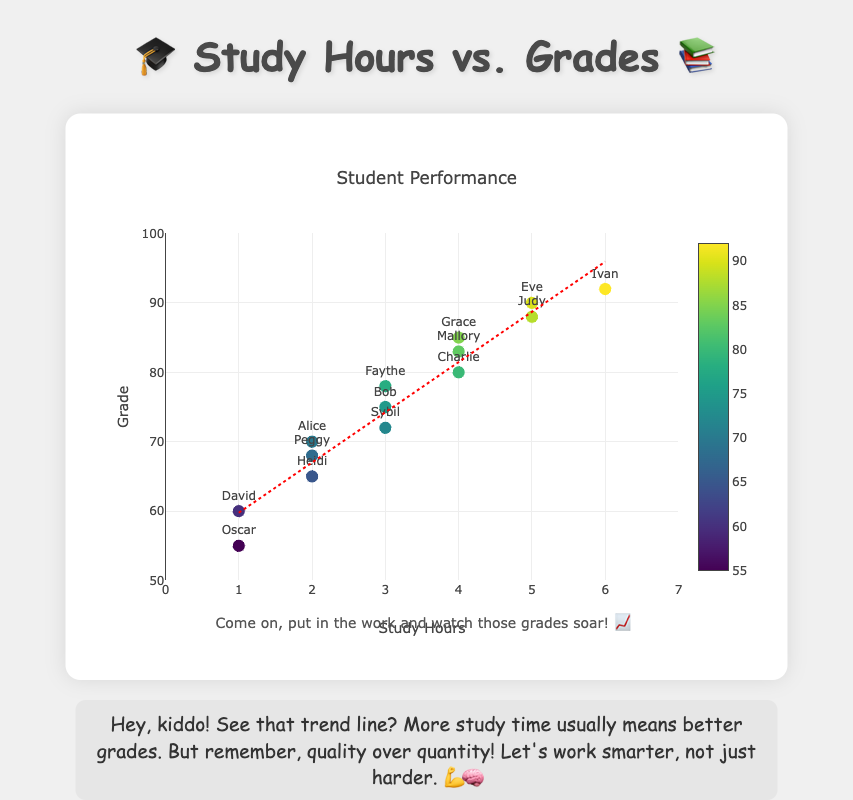How many students studied for 3 hours? We can count the number of data points where the x-coordinate (study hours) is 3.
Answer: 3 What is the title of the figure? The title is written at the top of the figure.
Answer: Student Performance Which student studied for the most hours and what was their grade? Look for the highest x-coordinate (study hours) and find the corresponding y-coordinate (grade) and student's name.
Answer: Ivan, 92 What is the range of study hours in the data? The range is from the minimum to the maximum value on the x-axis.
Answer: 1 to 6 What is the median grade of all students? The grades must be ordered, and the middle value should be identified. If there is an even number of grades, the median is the average of the two middle numbers. Grades are 55, 60, 65, 68, 70, 72, 75, 78, 80, 83, 85, 88, 90, 92. The median is (75 + 78) / 2.
Answer: 76.5 How many students achieved grades of 80 or above? Count how many y-coordinates (grades) are 80 or above.
Answer: 7 What is the average grade of students who studied for 2 hours? Select the grades corresponding to study hours of 2, sum them, and divide by the number of such students. Grades are 70, 65, 68. Average is (70 + 65 + 68) / 3.
Answer: 67.67 Who is the student with the lowest grade, and how many hours did they study? Identify the data point with the lowest y-coordinate (grade) and find the corresponding x-coordinate (study hours) and student's name.
Answer: Oscar, 1 Describe the general trend shown by the trend line. The trend line indicates that as study hours increase, grades also tend to increase.
Answer: Positive correlation Is there an outlier where a student studied much but didn't achieve a high grade? An outlier would be a notable deviation from the trend line. Check for points far from the line.
Answer: No significant outlier 